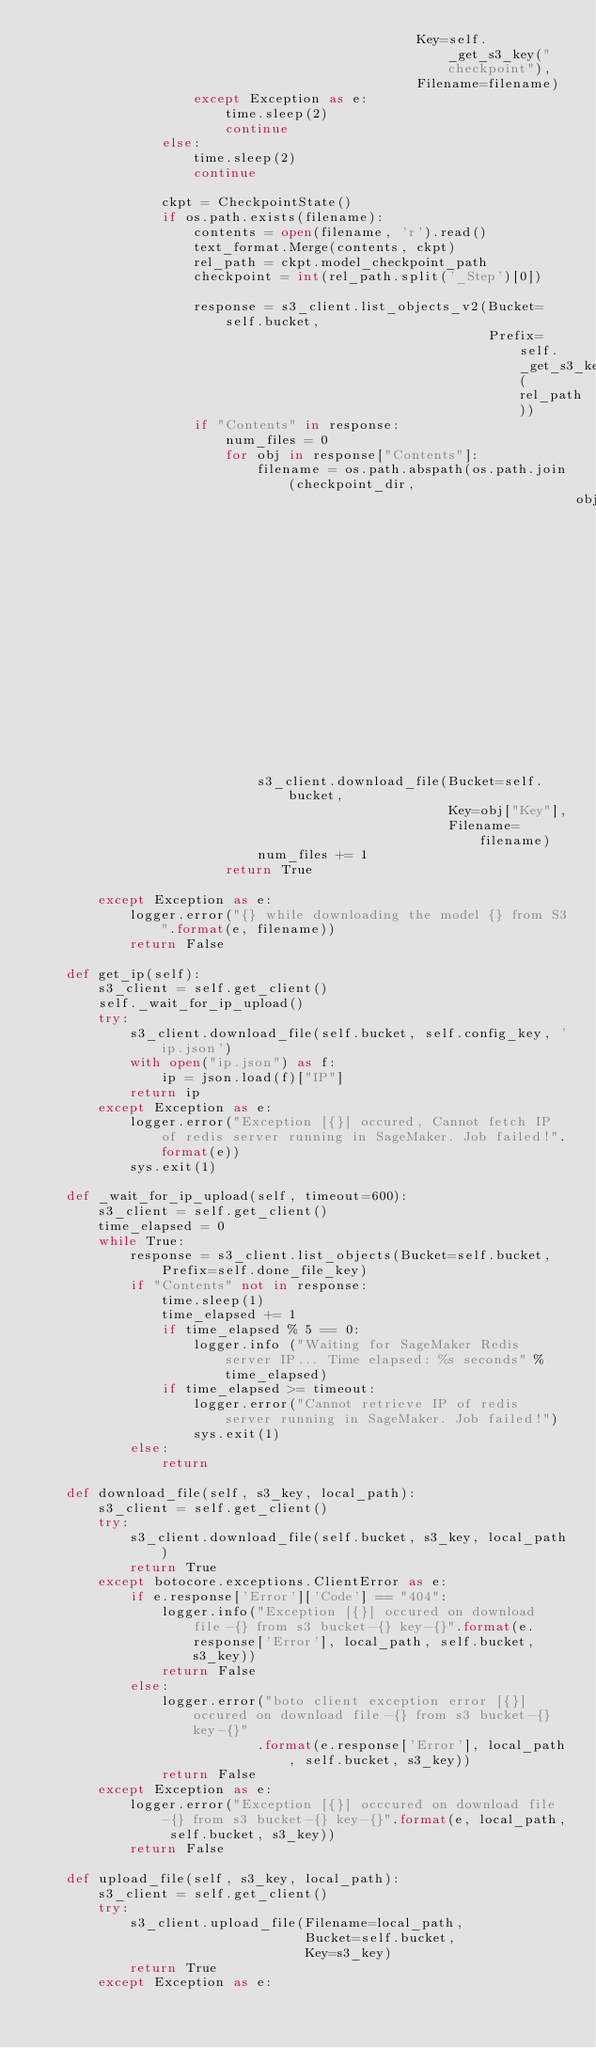Convert code to text. <code><loc_0><loc_0><loc_500><loc_500><_Python_>                                                Key=self._get_s3_key("checkpoint"),
                                                Filename=filename)
                    except Exception as e:
                        time.sleep(2)
                        continue
                else:
                    time.sleep(2)
                    continue

                ckpt = CheckpointState()
                if os.path.exists(filename):
                    contents = open(filename, 'r').read()
                    text_format.Merge(contents, ckpt)
                    rel_path = ckpt.model_checkpoint_path
                    checkpoint = int(rel_path.split('_Step')[0])

                    response = s3_client.list_objects_v2(Bucket=self.bucket,
                                                         Prefix=self._get_s3_key(rel_path))
                    if "Contents" in response:
                        num_files = 0
                        for obj in response["Contents"]:
                            filename = os.path.abspath(os.path.join(checkpoint_dir,
                                                                    obj["Key"].replace(self.model_checkpoints_prefix,
                                                                                       "")))
                            s3_client.download_file(Bucket=self.bucket,
                                                    Key=obj["Key"],
                                                    Filename=filename)
                            num_files += 1
                        return True

        except Exception as e:
            logger.error("{} while downloading the model {} from S3".format(e, filename))
            return False

    def get_ip(self):
        s3_client = self.get_client()
        self._wait_for_ip_upload()
        try:
            s3_client.download_file(self.bucket, self.config_key, 'ip.json')
            with open("ip.json") as f:
                ip = json.load(f)["IP"]
            return ip
        except Exception as e:
            logger.error("Exception [{}] occured, Cannot fetch IP of redis server running in SageMaker. Job failed!".format(e))
            sys.exit(1)

    def _wait_for_ip_upload(self, timeout=600):
        s3_client = self.get_client()
        time_elapsed = 0
        while True:
            response = s3_client.list_objects(Bucket=self.bucket, Prefix=self.done_file_key)
            if "Contents" not in response:
                time.sleep(1)
                time_elapsed += 1
                if time_elapsed % 5 == 0:
                    logger.info ("Waiting for SageMaker Redis server IP... Time elapsed: %s seconds" % time_elapsed)
                if time_elapsed >= timeout:
                    logger.error("Cannot retrieve IP of redis server running in SageMaker. Job failed!")
                    sys.exit(1)
            else:
                return

    def download_file(self, s3_key, local_path):
        s3_client = self.get_client()
        try:
            s3_client.download_file(self.bucket, s3_key, local_path)
            return True
        except botocore.exceptions.ClientError as e:
            if e.response['Error']['Code'] == "404":
                logger.info("Exception [{}] occured on download file-{} from s3 bucket-{} key-{}".format(e.response['Error'], local_path, self.bucket, s3_key))
                return False
            else:
                logger.error("boto client exception error [{}] occured on download file-{} from s3 bucket-{} key-{}"
                            .format(e.response['Error'], local_path, self.bucket, s3_key))
                return False
        except Exception as e:
            logger.error("Exception [{}] occcured on download file-{} from s3 bucket-{} key-{}".format(e, local_path, self.bucket, s3_key))
            return False

    def upload_file(self, s3_key, local_path):
        s3_client = self.get_client()
        try:
            s3_client.upload_file(Filename=local_path,
                                  Bucket=self.bucket,
                                  Key=s3_key)
            return True
        except Exception as e:</code> 